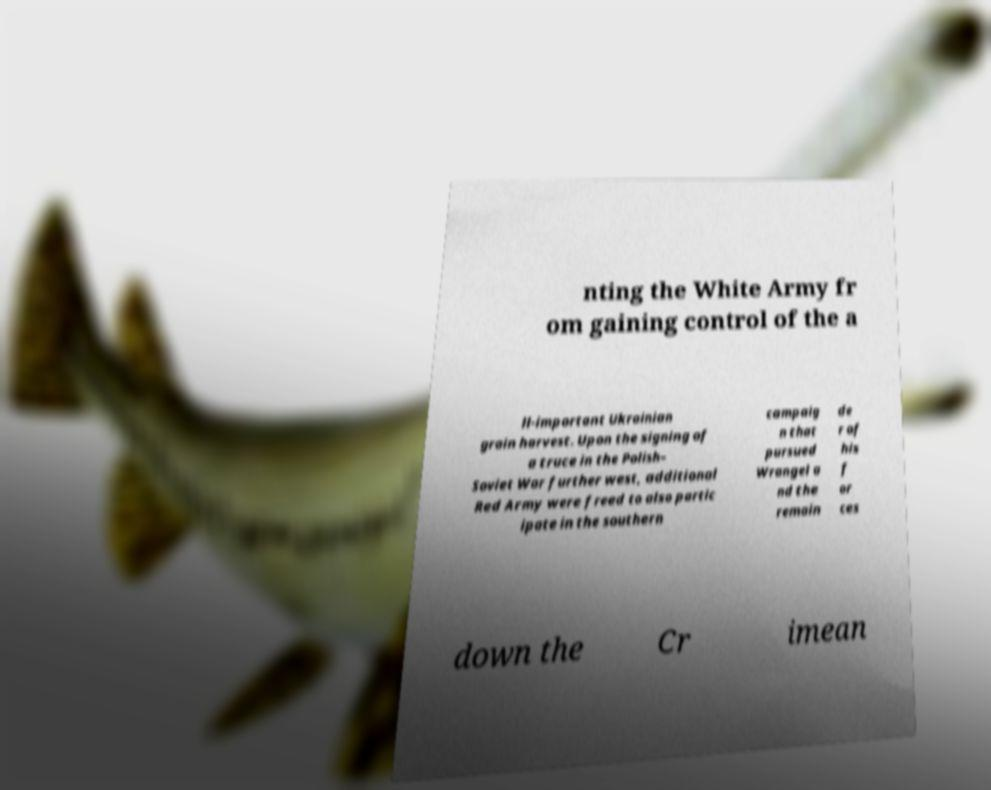Can you read and provide the text displayed in the image?This photo seems to have some interesting text. Can you extract and type it out for me? nting the White Army fr om gaining control of the a ll-important Ukrainian grain harvest. Upon the signing of a truce in the Polish– Soviet War further west, additional Red Army were freed to also partic ipate in the southern campaig n that pursued Wrangel a nd the remain de r of his f or ces down the Cr imean 